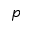Convert formula to latex. <formula><loc_0><loc_0><loc_500><loc_500>p</formula> 